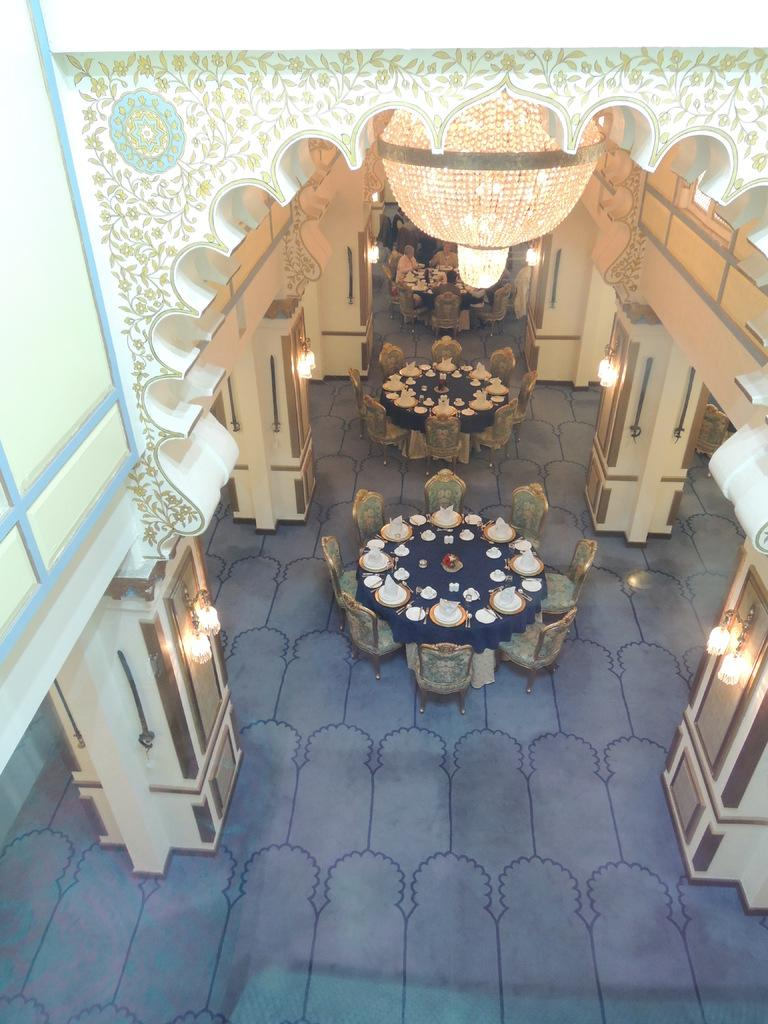What type of furniture is present in the image? There are dining tables in the image. Where are the lights located on the left side of the image? The lights are hanging on the left side of the image. Where are the lights located on the right side of the image? The lights are hanging on the right side of the image. What is visible at the top of the image? There is a light visible at the top of the image. How many men are present in the image? There is no mention of men in the provided facts, so we cannot determine the number of men in the image. 